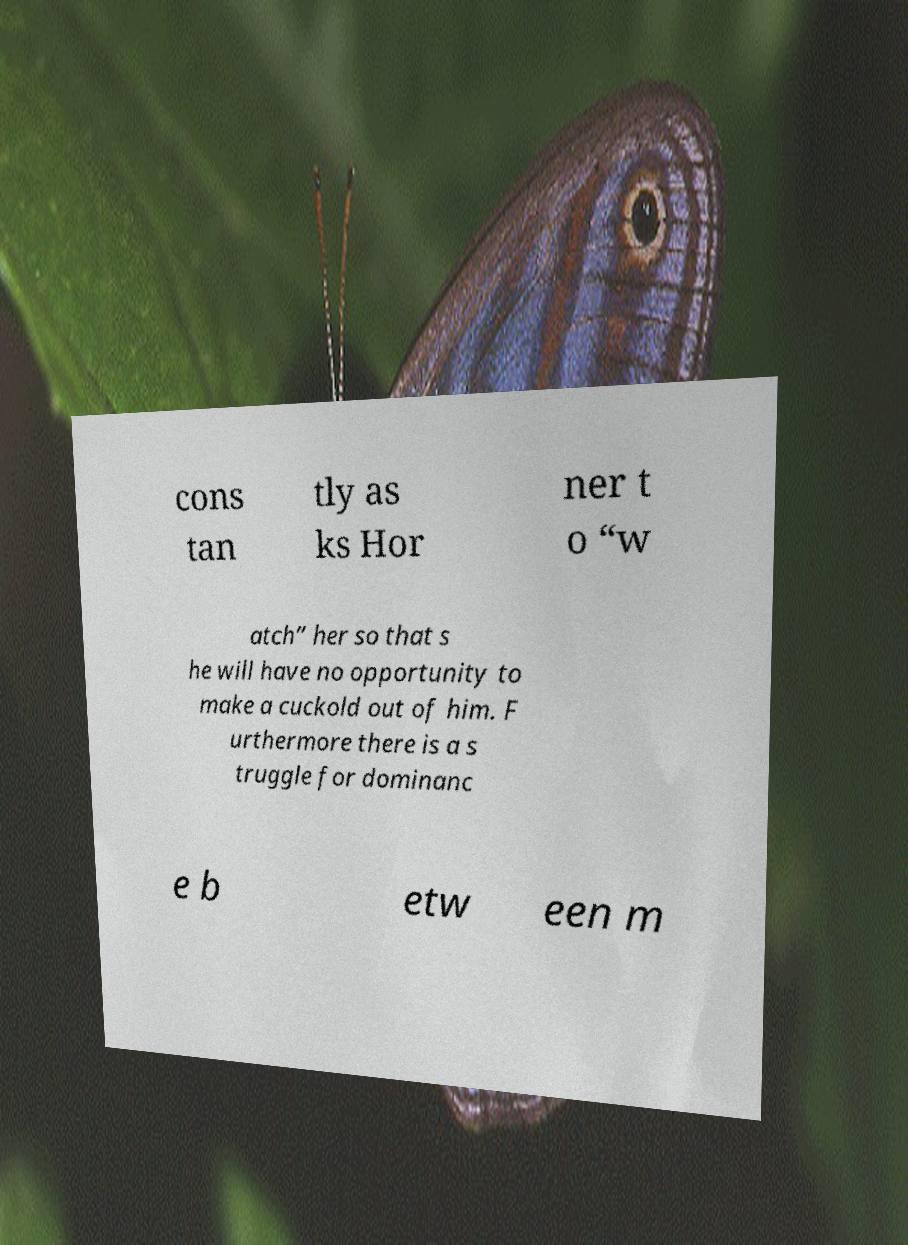Please identify and transcribe the text found in this image. cons tan tly as ks Hor ner t o “w atch” her so that s he will have no opportunity to make a cuckold out of him. F urthermore there is a s truggle for dominanc e b etw een m 